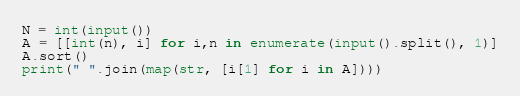Convert code to text. <code><loc_0><loc_0><loc_500><loc_500><_Python_>N = int(input())
A = [[int(n), i] for i,n in enumerate(input().split(), 1)]
A.sort()
print(" ".join(map(str, [i[1] for i in A])))</code> 